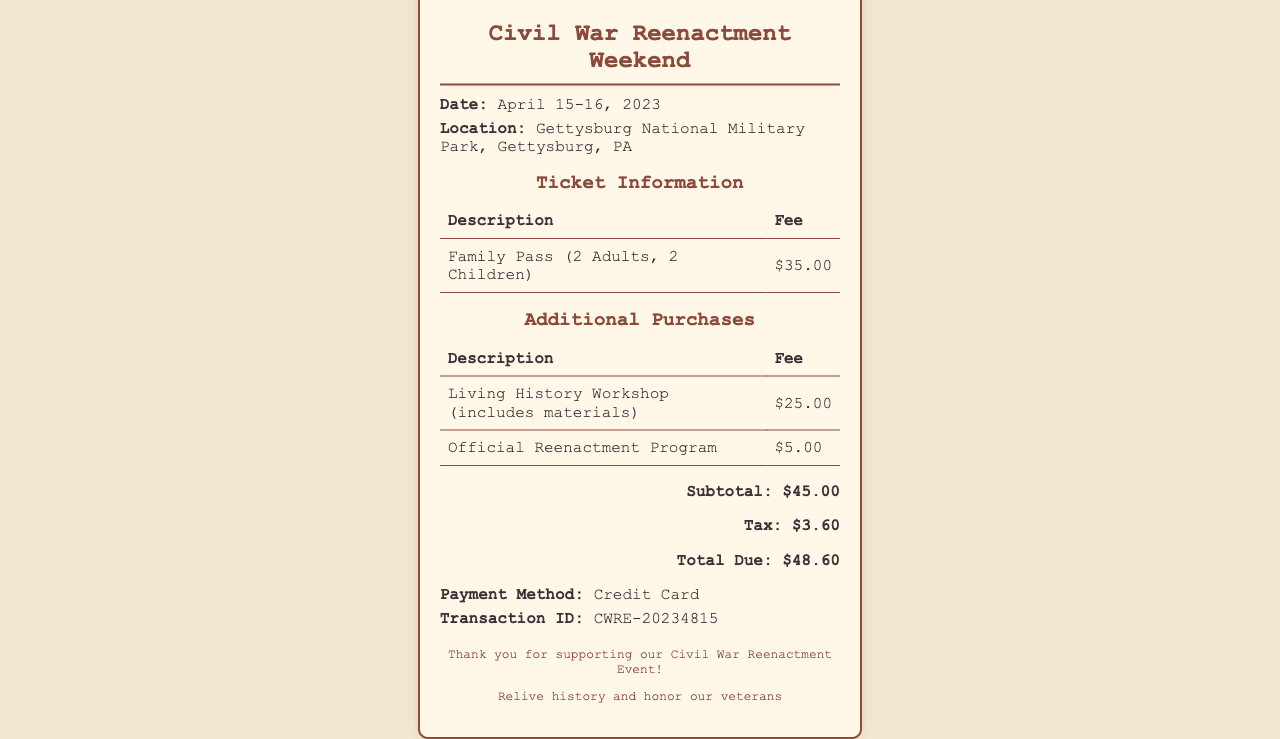What is the date of the event? The date of the event is clearly stated in the document as April 15-16, 2023.
Answer: April 15-16, 2023 Where is the reenactment located? The location is mentioned in the document as Gettysburg National Military Park, Gettysburg, PA.
Answer: Gettysburg National Military Park, Gettysburg, PA What is the fee for the Family Pass? The fee for the Family Pass is listed in the ticket information table as $35.00.
Answer: $35.00 How much is the Living History Workshop? The fee for the Living History Workshop is specified in the additional purchases section as $25.00.
Answer: $25.00 What is the total due amount? The total due amount is summarized at the end of the receipt as $48.60.
Answer: $48.60 What method of payment was used? The payment method is clearly stated in the information section as Credit Card.
Answer: Credit Card How much tax was included in the total? The tax amount is displayed in the totals section as $3.60.
Answer: $3.60 What is the transaction ID? The transaction ID is provided in the payment information as CWRE-20234815.
Answer: CWRE-20234815 What type of pass is mentioned in the ticket information? The ticket information mentions a Family Pass for 2 Adults and 2 Children.
Answer: Family Pass (2 Adults, 2 Children) 